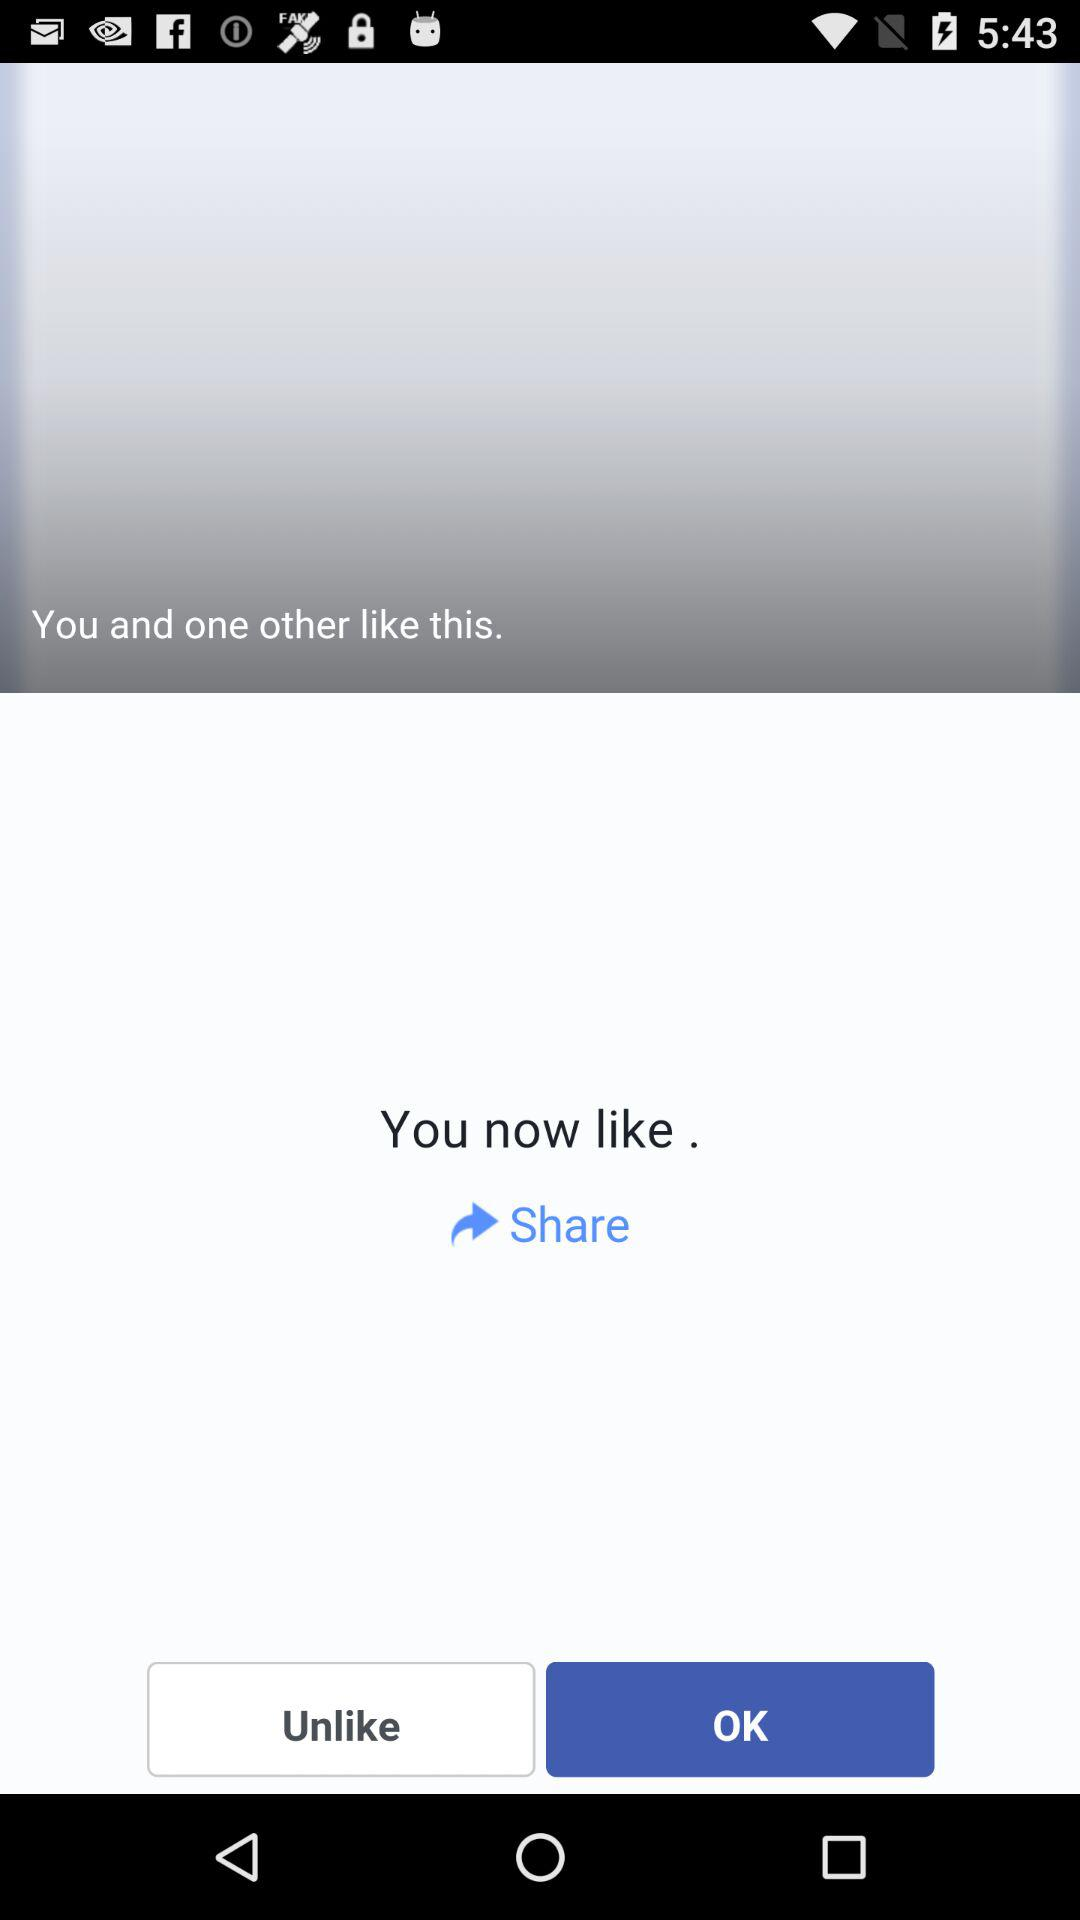How many people like this post?
Answer the question using a single word or phrase. 2 